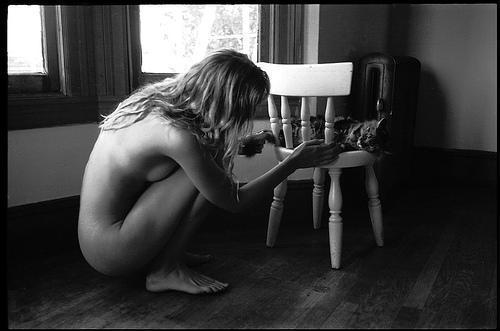How many legs does the chair have?
Give a very brief answer. 4. 